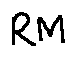Convert formula to latex. <formula><loc_0><loc_0><loc_500><loc_500>R M</formula> 